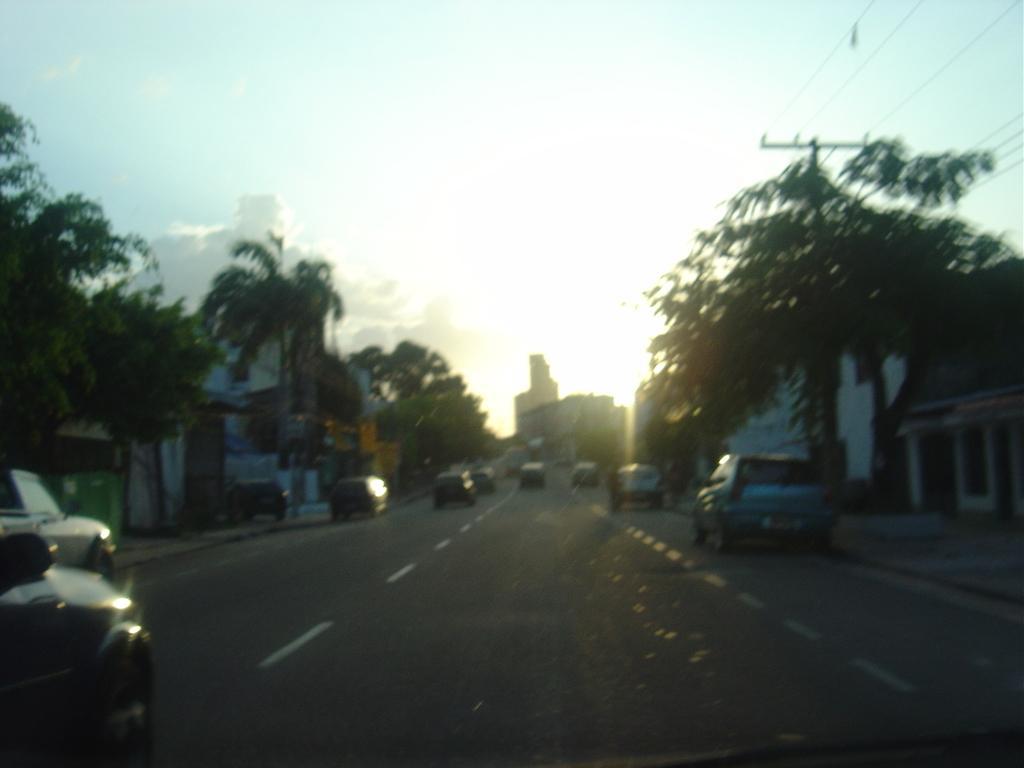In one or two sentences, can you explain what this image depicts? There are cars on the road. Here we can see trees, buildings, and pole. In the background there is sky with clouds. 